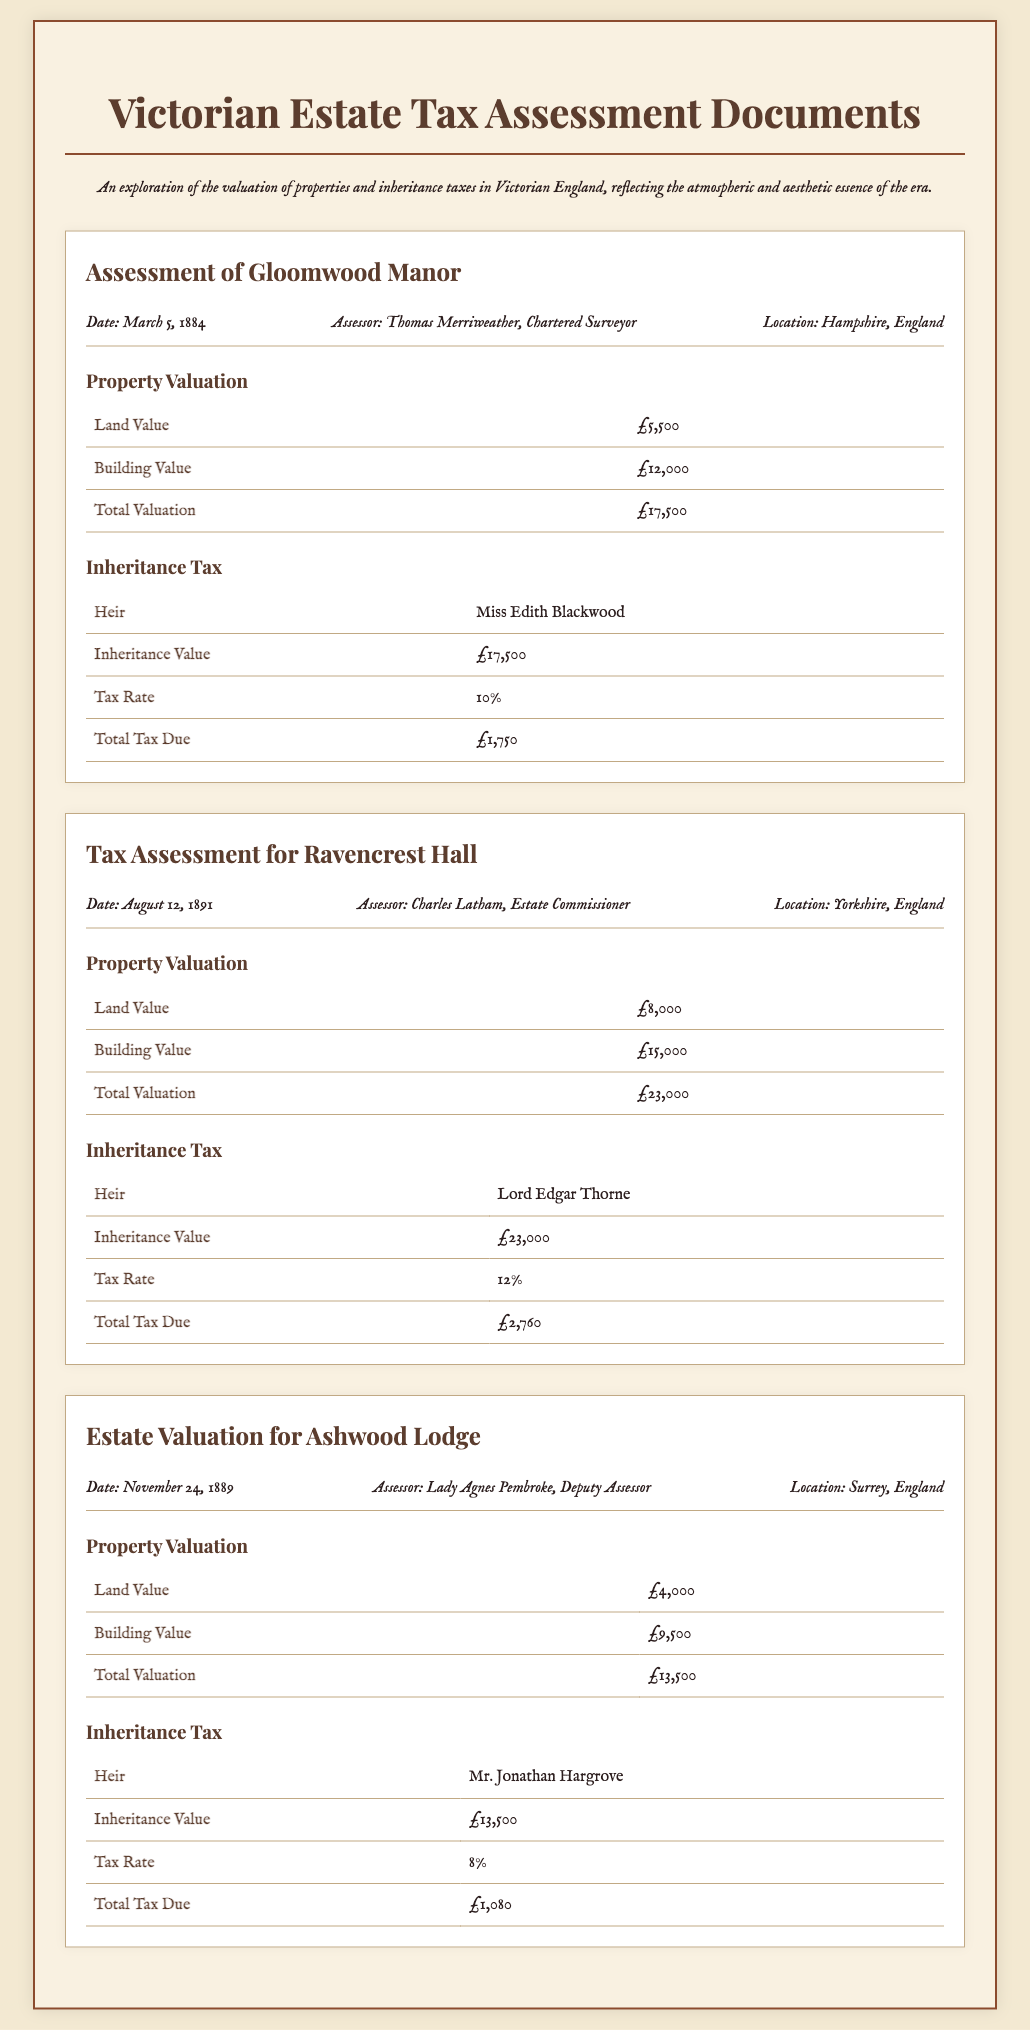What is the location of Gloomwood Manor? Gloomwood Manor is located in Hampshire, England, as stated in the document.
Answer: Hampshire, England Who is the heir of Ashwood Lodge? The heir of Ashwood Lodge is mentioned explicitly in the document.
Answer: Mr. Jonathan Hargrove What is the tax rate for inheritance at Ravencrest Hall? The document specifies the tax rate for Ravencrest Hall's inheritance tax.
Answer: 12% When was the tax assessment for Ravencrest Hall conducted? The date of the assessment for Ravencrest Hall is provided in the document.
Answer: August 12, 1891 What is the total valuation of Gloomwood Manor? The total valuation is calculated from the land value and building value given in the document.
Answer: £17,500 Which assessor evaluated Ashwood Lodge? The document mentions the name of the assessor for Ashwood Lodge.
Answer: Lady Agnes Pembroke What is the total tax due for the inheritance at Gloomwood Manor? The document outlines the total tax due for Gloomwood Manor.
Answer: £1,750 What is the building value of Ravencrest Hall? The document provides specific values for different aspects of Ravencrest Hall, including its building value.
Answer: £15,000 What year was the assessment for Ashwood Lodge? The document includes the date of the assessment for Ashwood Lodge.
Answer: 1889 